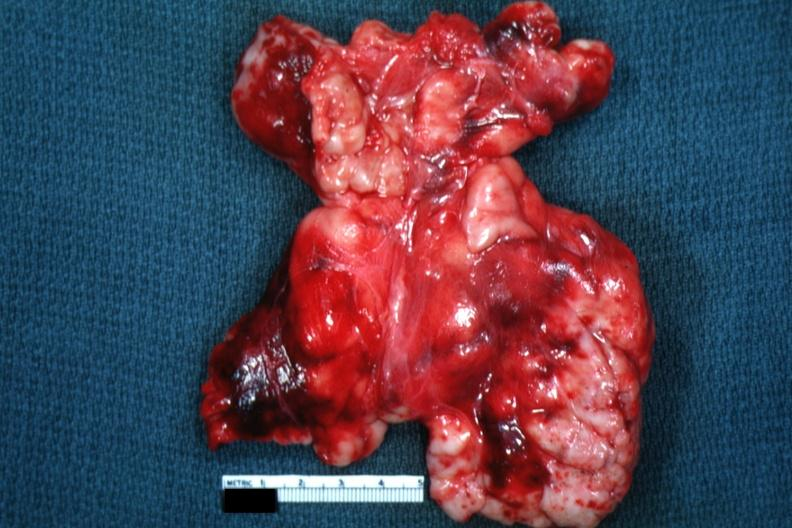how does this image appear as mass of matted nodes like malignant lymphoma?
Answer the question using a single word or phrase. Large 